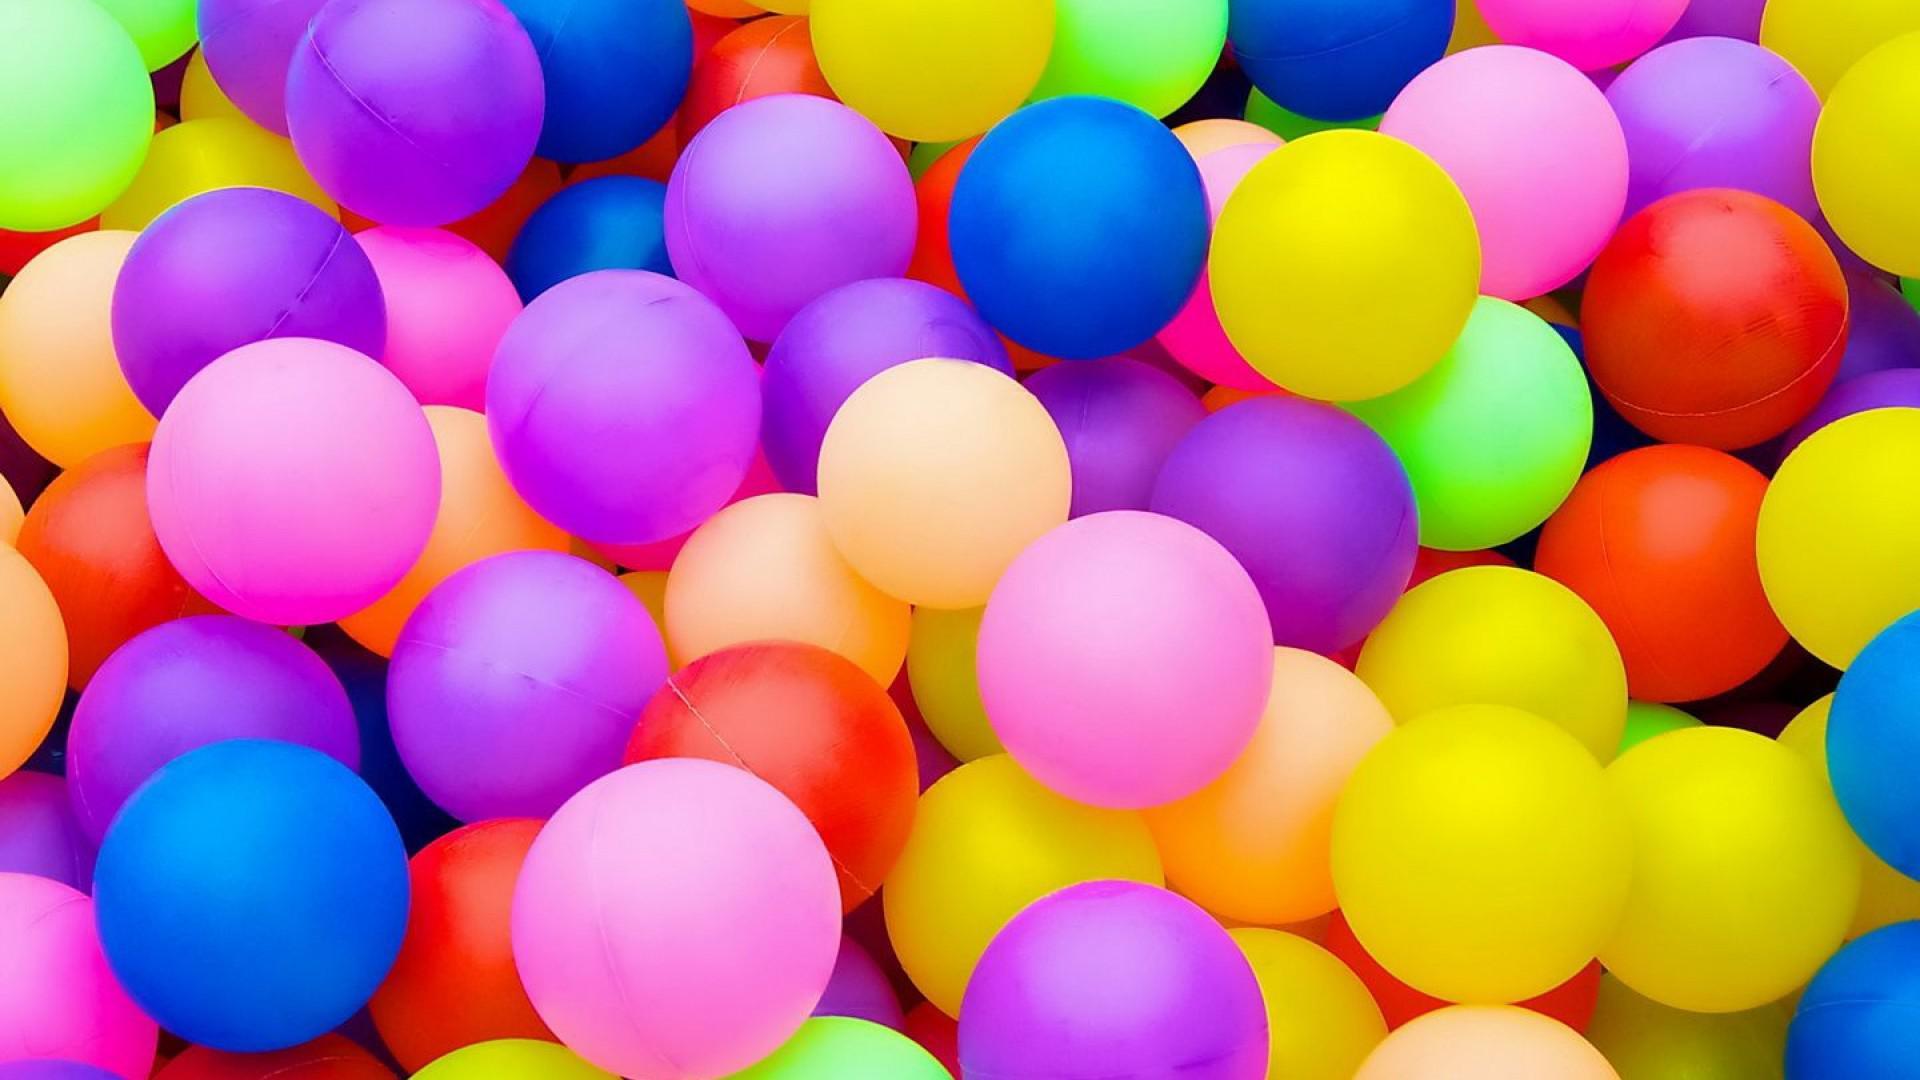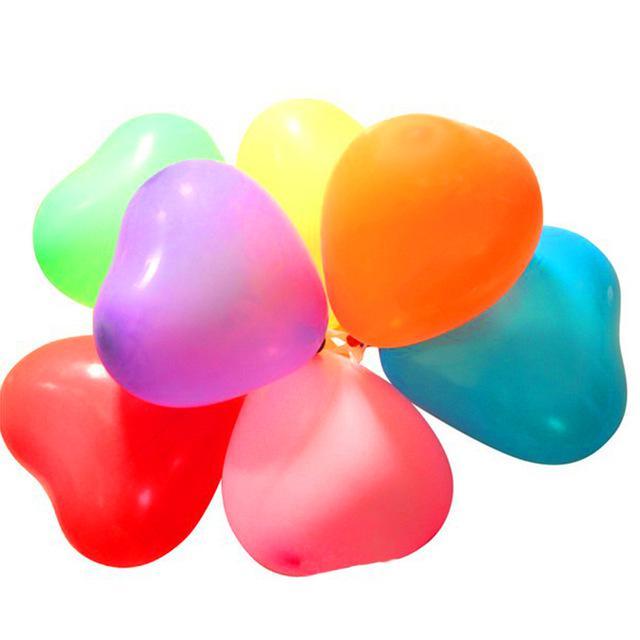The first image is the image on the left, the second image is the image on the right. Evaluate the accuracy of this statement regarding the images: "In at least one image there are eight balloon with strings on them.". Is it true? Answer yes or no. No. The first image is the image on the left, the second image is the image on the right. Analyze the images presented: Is the assertion "The right image contains eight or less balloons, while the left image contains more." valid? Answer yes or no. Yes. 